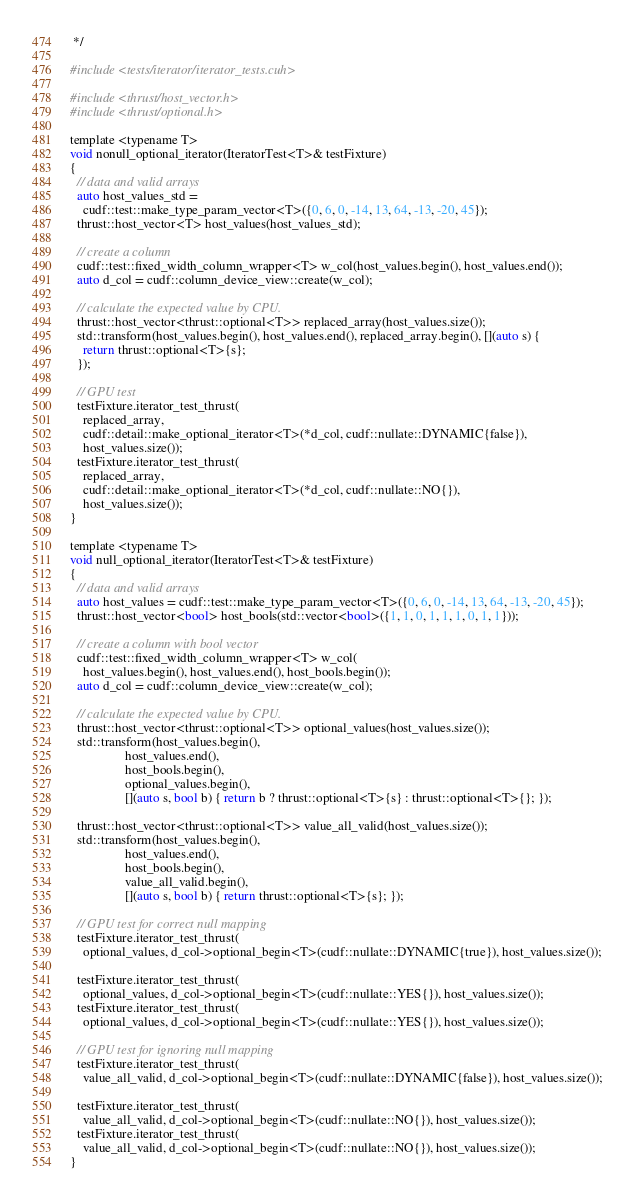Convert code to text. <code><loc_0><loc_0><loc_500><loc_500><_Cuda_> */

#include <tests/iterator/iterator_tests.cuh>

#include <thrust/host_vector.h>
#include <thrust/optional.h>

template <typename T>
void nonull_optional_iterator(IteratorTest<T>& testFixture)
{
  // data and valid arrays
  auto host_values_std =
    cudf::test::make_type_param_vector<T>({0, 6, 0, -14, 13, 64, -13, -20, 45});
  thrust::host_vector<T> host_values(host_values_std);

  // create a column
  cudf::test::fixed_width_column_wrapper<T> w_col(host_values.begin(), host_values.end());
  auto d_col = cudf::column_device_view::create(w_col);

  // calculate the expected value by CPU.
  thrust::host_vector<thrust::optional<T>> replaced_array(host_values.size());
  std::transform(host_values.begin(), host_values.end(), replaced_array.begin(), [](auto s) {
    return thrust::optional<T>{s};
  });

  // GPU test
  testFixture.iterator_test_thrust(
    replaced_array,
    cudf::detail::make_optional_iterator<T>(*d_col, cudf::nullate::DYNAMIC{false}),
    host_values.size());
  testFixture.iterator_test_thrust(
    replaced_array,
    cudf::detail::make_optional_iterator<T>(*d_col, cudf::nullate::NO{}),
    host_values.size());
}

template <typename T>
void null_optional_iterator(IteratorTest<T>& testFixture)
{
  // data and valid arrays
  auto host_values = cudf::test::make_type_param_vector<T>({0, 6, 0, -14, 13, 64, -13, -20, 45});
  thrust::host_vector<bool> host_bools(std::vector<bool>({1, 1, 0, 1, 1, 1, 0, 1, 1}));

  // create a column with bool vector
  cudf::test::fixed_width_column_wrapper<T> w_col(
    host_values.begin(), host_values.end(), host_bools.begin());
  auto d_col = cudf::column_device_view::create(w_col);

  // calculate the expected value by CPU.
  thrust::host_vector<thrust::optional<T>> optional_values(host_values.size());
  std::transform(host_values.begin(),
                 host_values.end(),
                 host_bools.begin(),
                 optional_values.begin(),
                 [](auto s, bool b) { return b ? thrust::optional<T>{s} : thrust::optional<T>{}; });

  thrust::host_vector<thrust::optional<T>> value_all_valid(host_values.size());
  std::transform(host_values.begin(),
                 host_values.end(),
                 host_bools.begin(),
                 value_all_valid.begin(),
                 [](auto s, bool b) { return thrust::optional<T>{s}; });

  // GPU test for correct null mapping
  testFixture.iterator_test_thrust(
    optional_values, d_col->optional_begin<T>(cudf::nullate::DYNAMIC{true}), host_values.size());

  testFixture.iterator_test_thrust(
    optional_values, d_col->optional_begin<T>(cudf::nullate::YES{}), host_values.size());
  testFixture.iterator_test_thrust(
    optional_values, d_col->optional_begin<T>(cudf::nullate::YES{}), host_values.size());

  // GPU test for ignoring null mapping
  testFixture.iterator_test_thrust(
    value_all_valid, d_col->optional_begin<T>(cudf::nullate::DYNAMIC{false}), host_values.size());

  testFixture.iterator_test_thrust(
    value_all_valid, d_col->optional_begin<T>(cudf::nullate::NO{}), host_values.size());
  testFixture.iterator_test_thrust(
    value_all_valid, d_col->optional_begin<T>(cudf::nullate::NO{}), host_values.size());
}
</code> 